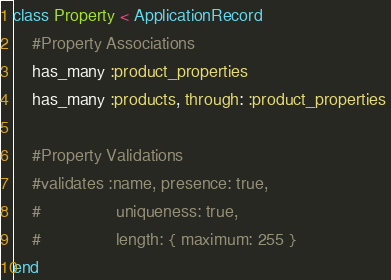Convert code to text. <code><loc_0><loc_0><loc_500><loc_500><_Ruby_>class Property < ApplicationRecord
	#Property Associations
	has_many :product_properties 
	has_many :products, through: :product_properties 

	#Property Validations
	#validates :name, presence: true, 
	#				 uniqueness: true, 
	#				 length: { maximum: 255 }
end
</code> 